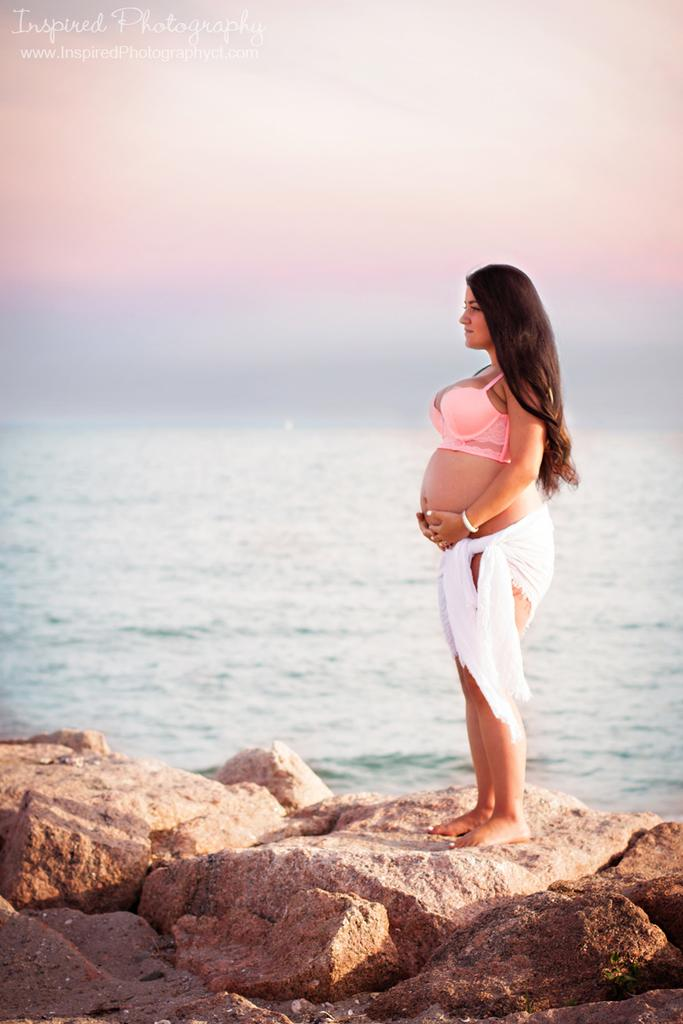Who is the main subject in the image? There is a woman in the image. What is the woman doing in the image? The woman is standing. What color is the top that the woman is wearing? The woman is wearing a pink top. What other clothing item is the woman wearing? The woman is wearing a white cloth. What can be seen in the background of the image? There is water visible in the image. How many dolls are sitting on the woman's shoulder in the image? There are no dolls present in the image, so it is not possible to answer that question. 